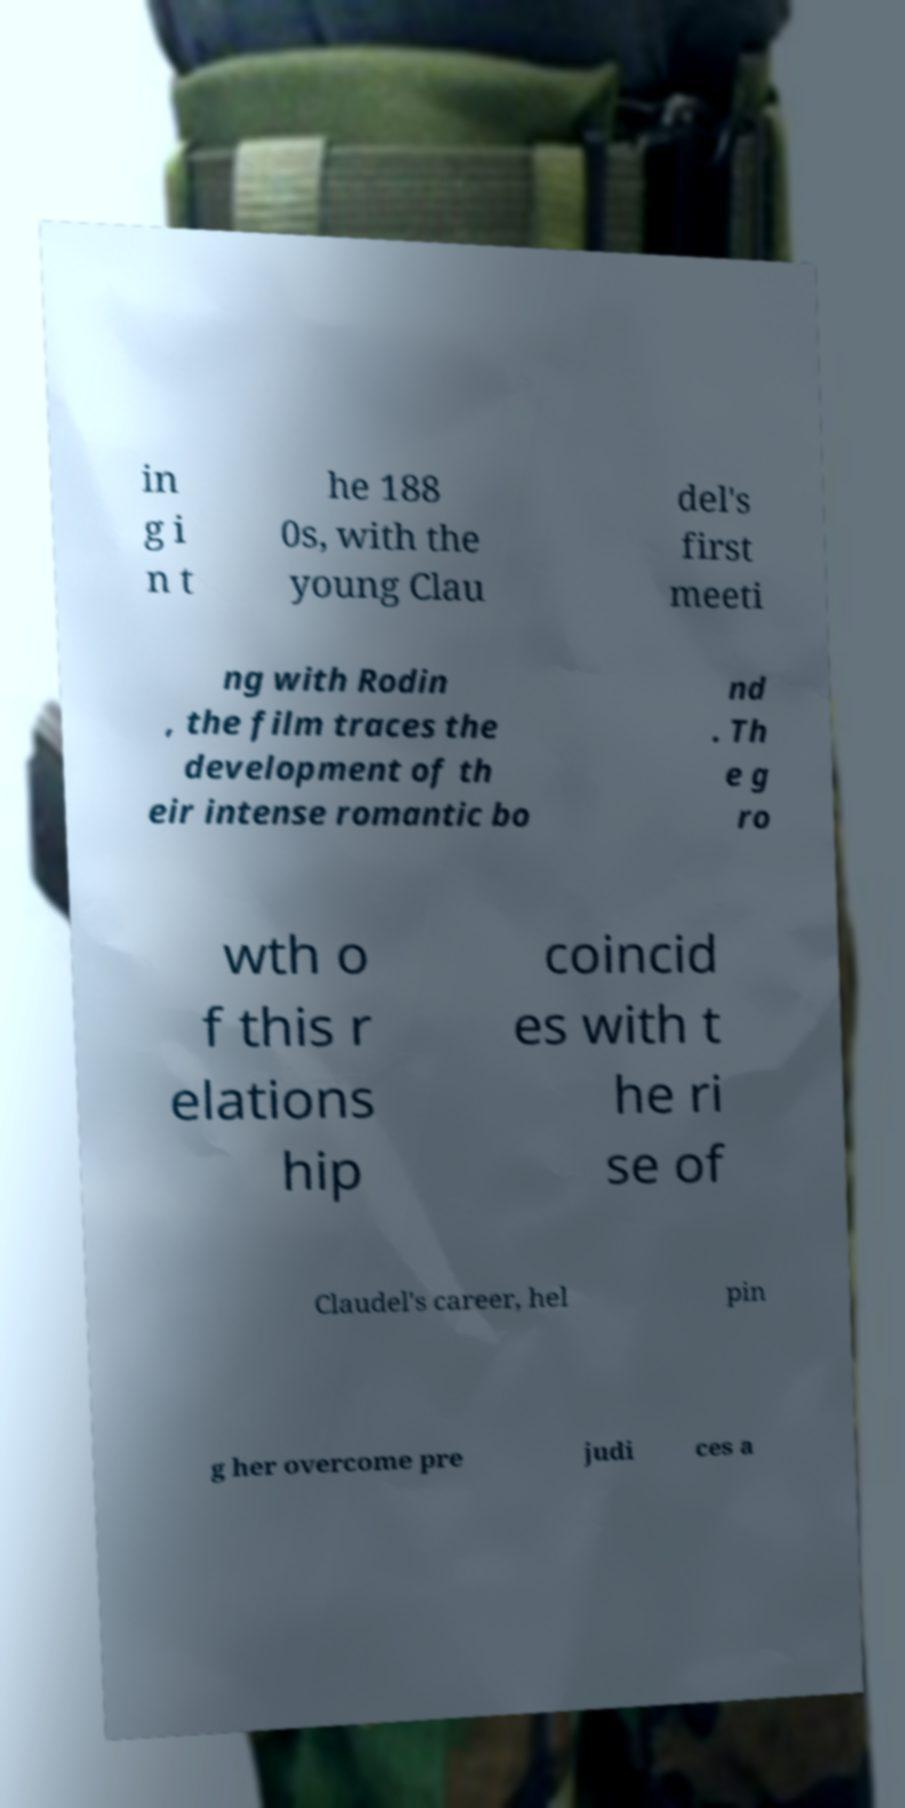Can you accurately transcribe the text from the provided image for me? in g i n t he 188 0s, with the young Clau del's first meeti ng with Rodin , the film traces the development of th eir intense romantic bo nd . Th e g ro wth o f this r elations hip coincid es with t he ri se of Claudel's career, hel pin g her overcome pre judi ces a 